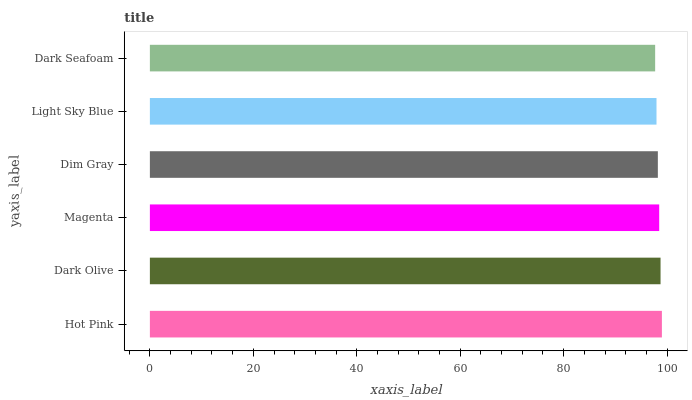Is Dark Seafoam the minimum?
Answer yes or no. Yes. Is Hot Pink the maximum?
Answer yes or no. Yes. Is Dark Olive the minimum?
Answer yes or no. No. Is Dark Olive the maximum?
Answer yes or no. No. Is Hot Pink greater than Dark Olive?
Answer yes or no. Yes. Is Dark Olive less than Hot Pink?
Answer yes or no. Yes. Is Dark Olive greater than Hot Pink?
Answer yes or no. No. Is Hot Pink less than Dark Olive?
Answer yes or no. No. Is Magenta the high median?
Answer yes or no. Yes. Is Dim Gray the low median?
Answer yes or no. Yes. Is Light Sky Blue the high median?
Answer yes or no. No. Is Dark Olive the low median?
Answer yes or no. No. 